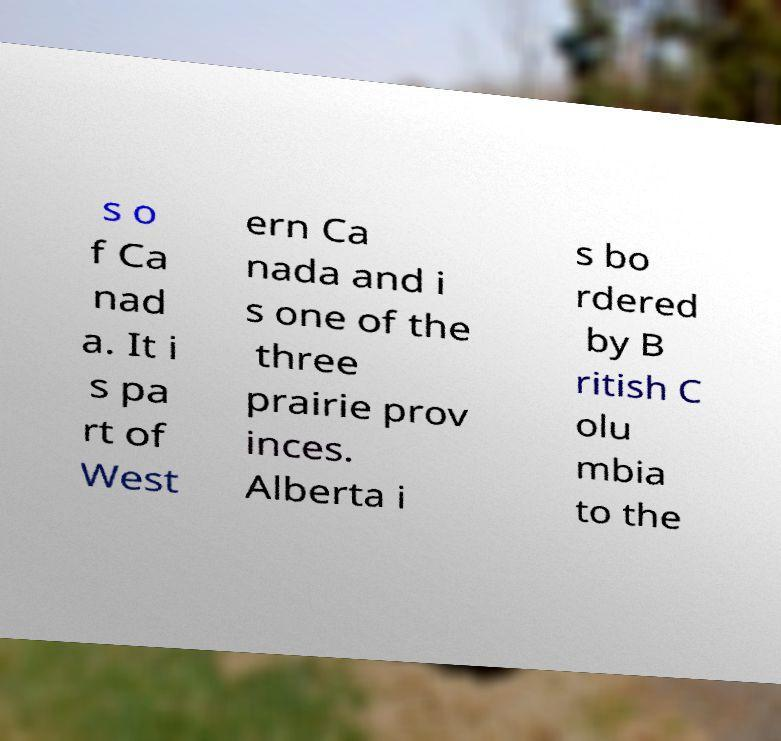What messages or text are displayed in this image? I need them in a readable, typed format. s o f Ca nad a. It i s pa rt of West ern Ca nada and i s one of the three prairie prov inces. Alberta i s bo rdered by B ritish C olu mbia to the 